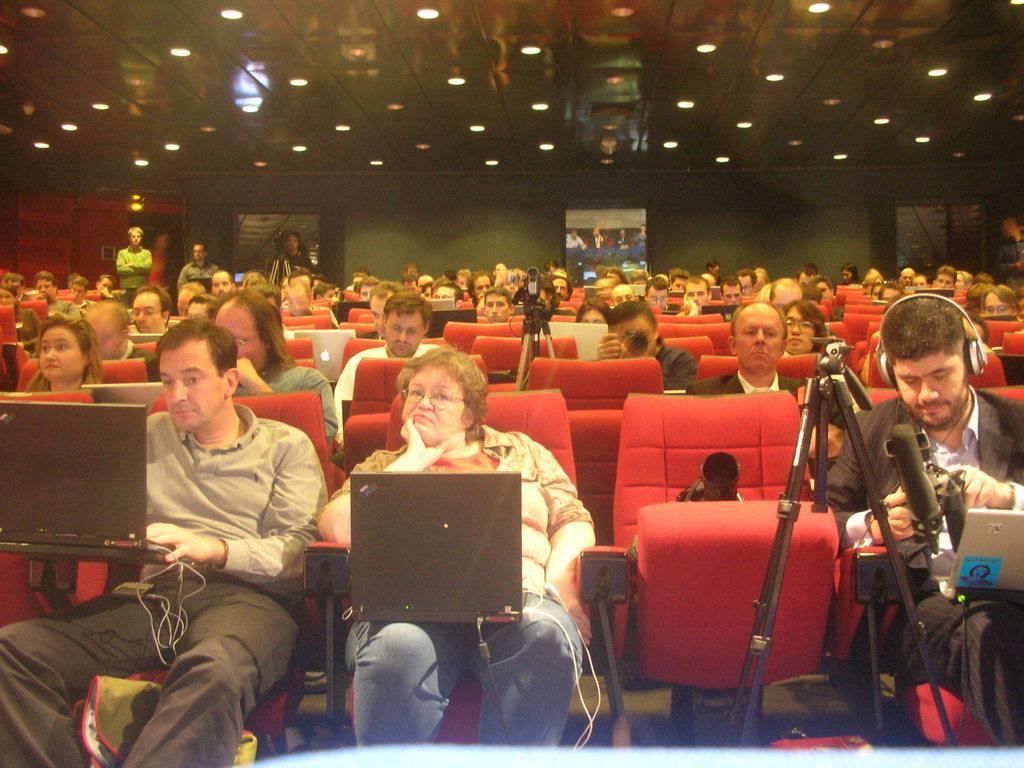Can you describe this image briefly? In the picture I can see people, among them some are standing and others are sitting on chairs. I can also see laptops, video cameras, lights on the ceiling, wall and some other objects. 